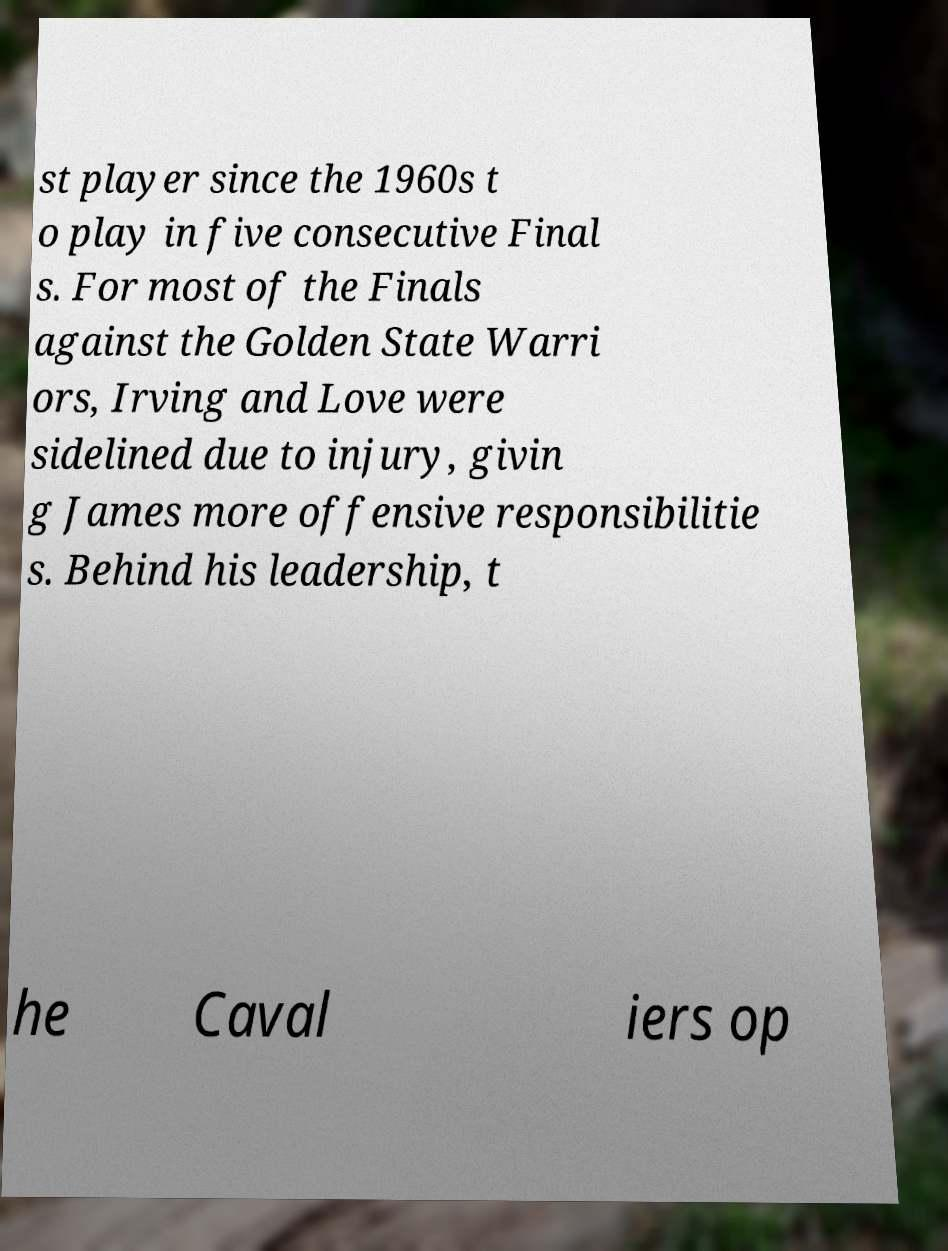Please read and relay the text visible in this image. What does it say? st player since the 1960s t o play in five consecutive Final s. For most of the Finals against the Golden State Warri ors, Irving and Love were sidelined due to injury, givin g James more offensive responsibilitie s. Behind his leadership, t he Caval iers op 